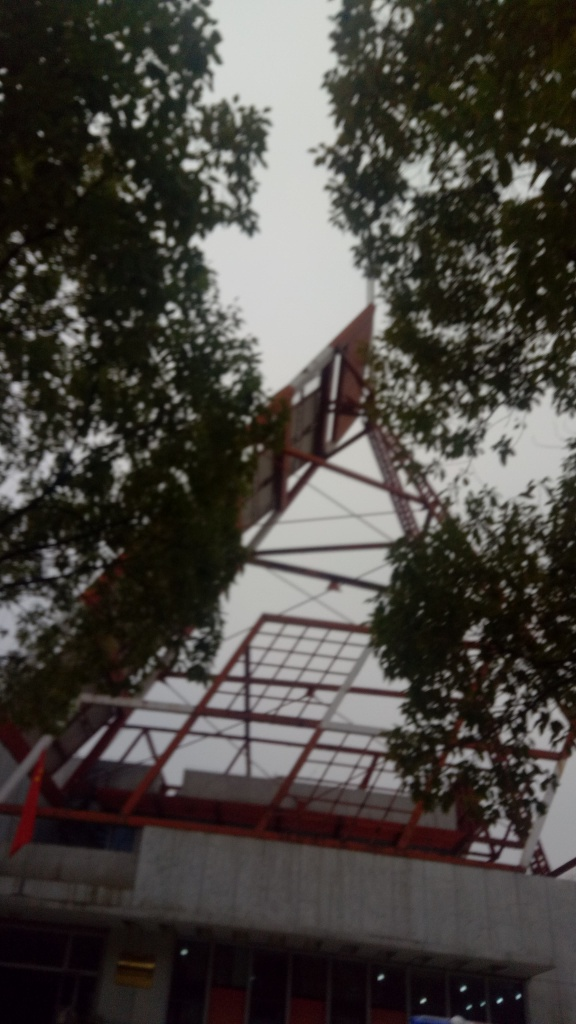What is this structure and what might it be used for? The structure in the image looks like steel framework potentially for a building or an installation. It appears to be in the construction or renovation phase, and such frameworks are commonly used as the skeletal support for large buildings, providing stability and shape before additional elements like walls and roofing are added. 